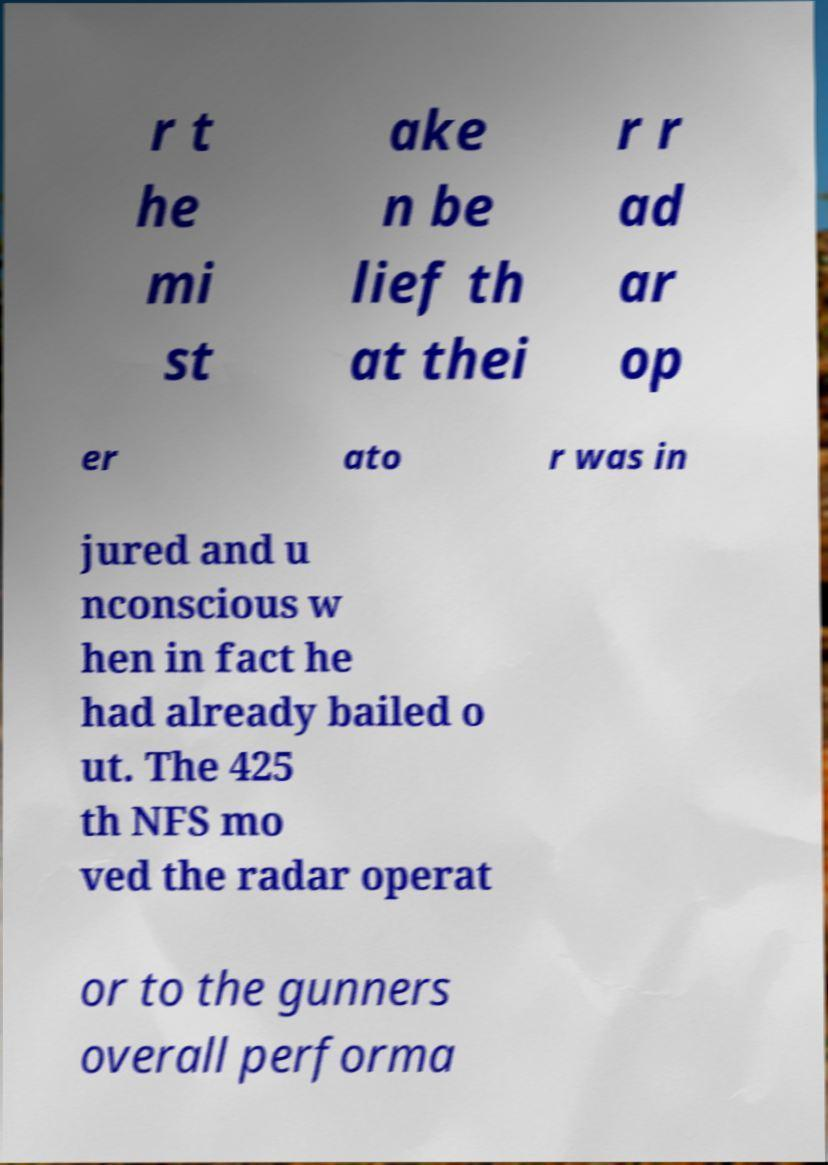For documentation purposes, I need the text within this image transcribed. Could you provide that? r t he mi st ake n be lief th at thei r r ad ar op er ato r was in jured and u nconscious w hen in fact he had already bailed o ut. The 425 th NFS mo ved the radar operat or to the gunners overall performa 